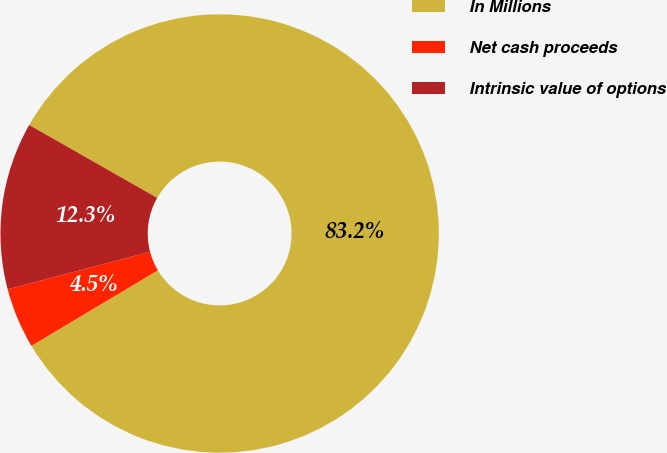Convert chart. <chart><loc_0><loc_0><loc_500><loc_500><pie_chart><fcel>In Millions<fcel>Net cash proceeds<fcel>Intrinsic value of options<nl><fcel>83.2%<fcel>4.47%<fcel>12.34%<nl></chart> 